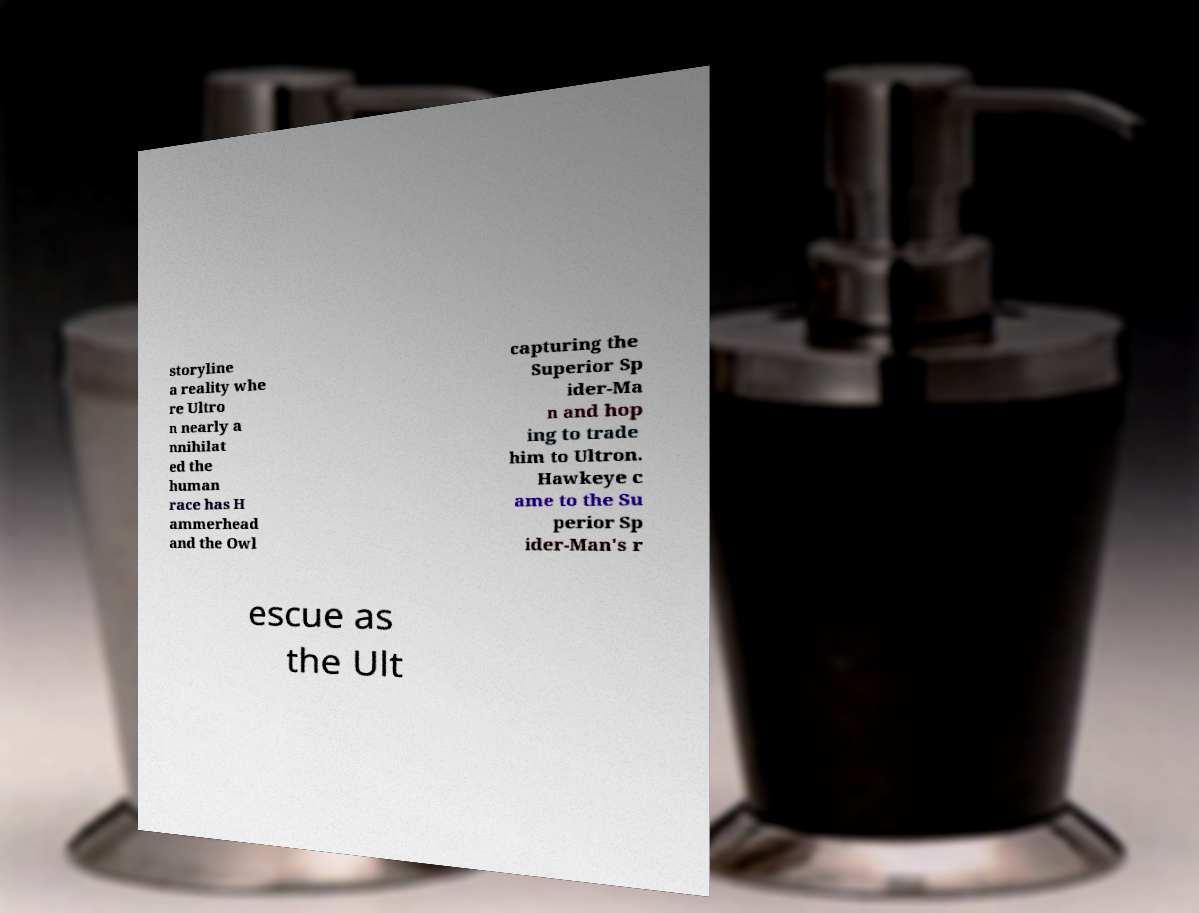Could you assist in decoding the text presented in this image and type it out clearly? storyline a reality whe re Ultro n nearly a nnihilat ed the human race has H ammerhead and the Owl capturing the Superior Sp ider-Ma n and hop ing to trade him to Ultron. Hawkeye c ame to the Su perior Sp ider-Man's r escue as the Ult 